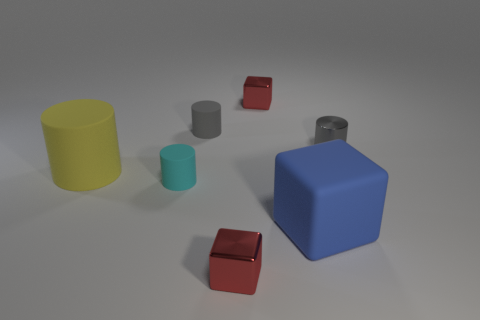Add 1 big cubes. How many objects exist? 8 Subtract all cylinders. How many objects are left? 3 Add 6 cyan objects. How many cyan objects are left? 7 Add 7 large things. How many large things exist? 9 Subtract 0 green cylinders. How many objects are left? 7 Subtract all tiny objects. Subtract all big gray matte objects. How many objects are left? 2 